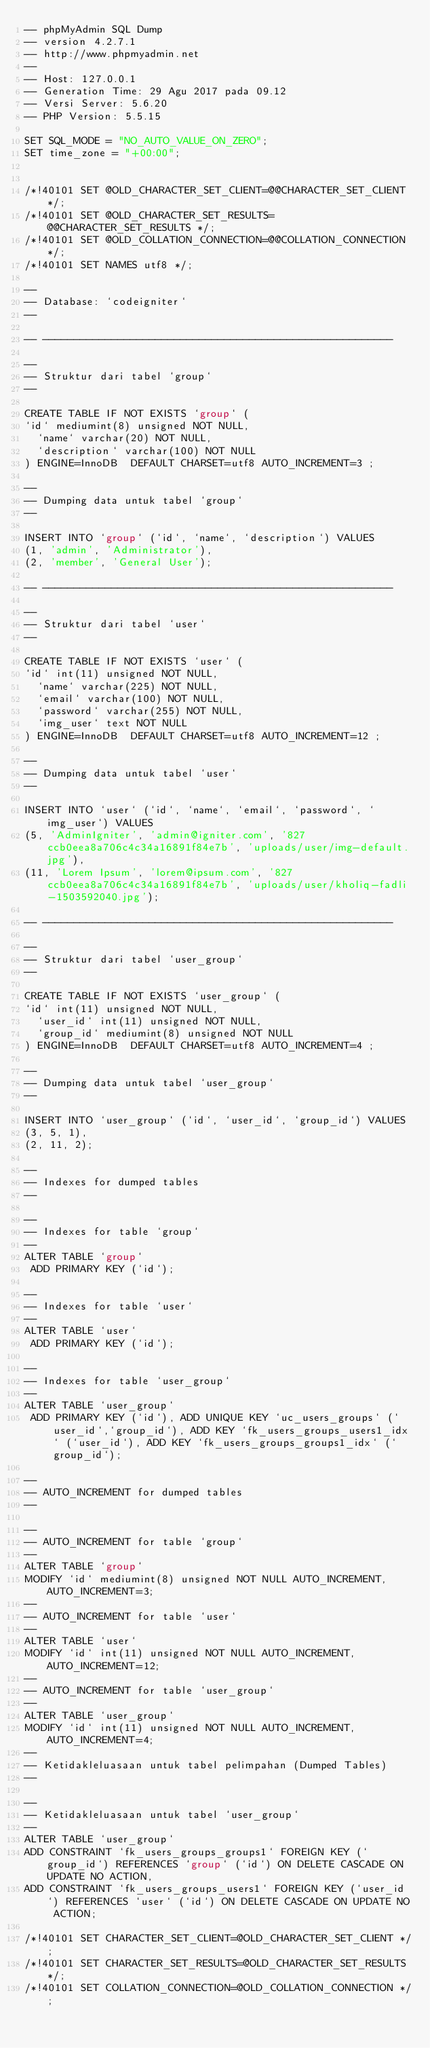<code> <loc_0><loc_0><loc_500><loc_500><_SQL_>-- phpMyAdmin SQL Dump
-- version 4.2.7.1
-- http://www.phpmyadmin.net
--
-- Host: 127.0.0.1
-- Generation Time: 29 Agu 2017 pada 09.12
-- Versi Server: 5.6.20
-- PHP Version: 5.5.15

SET SQL_MODE = "NO_AUTO_VALUE_ON_ZERO";
SET time_zone = "+00:00";


/*!40101 SET @OLD_CHARACTER_SET_CLIENT=@@CHARACTER_SET_CLIENT */;
/*!40101 SET @OLD_CHARACTER_SET_RESULTS=@@CHARACTER_SET_RESULTS */;
/*!40101 SET @OLD_COLLATION_CONNECTION=@@COLLATION_CONNECTION */;
/*!40101 SET NAMES utf8 */;

--
-- Database: `codeigniter`
--

-- --------------------------------------------------------

--
-- Struktur dari tabel `group`
--

CREATE TABLE IF NOT EXISTS `group` (
`id` mediumint(8) unsigned NOT NULL,
  `name` varchar(20) NOT NULL,
  `description` varchar(100) NOT NULL
) ENGINE=InnoDB  DEFAULT CHARSET=utf8 AUTO_INCREMENT=3 ;

--
-- Dumping data untuk tabel `group`
--

INSERT INTO `group` (`id`, `name`, `description`) VALUES
(1, 'admin', 'Administrator'),
(2, 'member', 'General User');

-- --------------------------------------------------------

--
-- Struktur dari tabel `user`
--

CREATE TABLE IF NOT EXISTS `user` (
`id` int(11) unsigned NOT NULL,
  `name` varchar(225) NOT NULL,
  `email` varchar(100) NOT NULL,
  `password` varchar(255) NOT NULL,
  `img_user` text NOT NULL
) ENGINE=InnoDB  DEFAULT CHARSET=utf8 AUTO_INCREMENT=12 ;

--
-- Dumping data untuk tabel `user`
--

INSERT INTO `user` (`id`, `name`, `email`, `password`, `img_user`) VALUES
(5, 'AdminIgniter', 'admin@igniter.com', '827ccb0eea8a706c4c34a16891f84e7b', 'uploads/user/img-default.jpg'),
(11, 'Lorem Ipsum', 'lorem@ipsum.com', '827ccb0eea8a706c4c34a16891f84e7b', 'uploads/user/kholiq-fadli-1503592040.jpg');

-- --------------------------------------------------------

--
-- Struktur dari tabel `user_group`
--

CREATE TABLE IF NOT EXISTS `user_group` (
`id` int(11) unsigned NOT NULL,
  `user_id` int(11) unsigned NOT NULL,
  `group_id` mediumint(8) unsigned NOT NULL
) ENGINE=InnoDB  DEFAULT CHARSET=utf8 AUTO_INCREMENT=4 ;

--
-- Dumping data untuk tabel `user_group`
--

INSERT INTO `user_group` (`id`, `user_id`, `group_id`) VALUES
(3, 5, 1),
(2, 11, 2);

--
-- Indexes for dumped tables
--

--
-- Indexes for table `group`
--
ALTER TABLE `group`
 ADD PRIMARY KEY (`id`);

--
-- Indexes for table `user`
--
ALTER TABLE `user`
 ADD PRIMARY KEY (`id`);

--
-- Indexes for table `user_group`
--
ALTER TABLE `user_group`
 ADD PRIMARY KEY (`id`), ADD UNIQUE KEY `uc_users_groups` (`user_id`,`group_id`), ADD KEY `fk_users_groups_users1_idx` (`user_id`), ADD KEY `fk_users_groups_groups1_idx` (`group_id`);

--
-- AUTO_INCREMENT for dumped tables
--

--
-- AUTO_INCREMENT for table `group`
--
ALTER TABLE `group`
MODIFY `id` mediumint(8) unsigned NOT NULL AUTO_INCREMENT,AUTO_INCREMENT=3;
--
-- AUTO_INCREMENT for table `user`
--
ALTER TABLE `user`
MODIFY `id` int(11) unsigned NOT NULL AUTO_INCREMENT,AUTO_INCREMENT=12;
--
-- AUTO_INCREMENT for table `user_group`
--
ALTER TABLE `user_group`
MODIFY `id` int(11) unsigned NOT NULL AUTO_INCREMENT,AUTO_INCREMENT=4;
--
-- Ketidakleluasaan untuk tabel pelimpahan (Dumped Tables)
--

--
-- Ketidakleluasaan untuk tabel `user_group`
--
ALTER TABLE `user_group`
ADD CONSTRAINT `fk_users_groups_groups1` FOREIGN KEY (`group_id`) REFERENCES `group` (`id`) ON DELETE CASCADE ON UPDATE NO ACTION,
ADD CONSTRAINT `fk_users_groups_users1` FOREIGN KEY (`user_id`) REFERENCES `user` (`id`) ON DELETE CASCADE ON UPDATE NO ACTION;

/*!40101 SET CHARACTER_SET_CLIENT=@OLD_CHARACTER_SET_CLIENT */;
/*!40101 SET CHARACTER_SET_RESULTS=@OLD_CHARACTER_SET_RESULTS */;
/*!40101 SET COLLATION_CONNECTION=@OLD_COLLATION_CONNECTION */;
</code> 